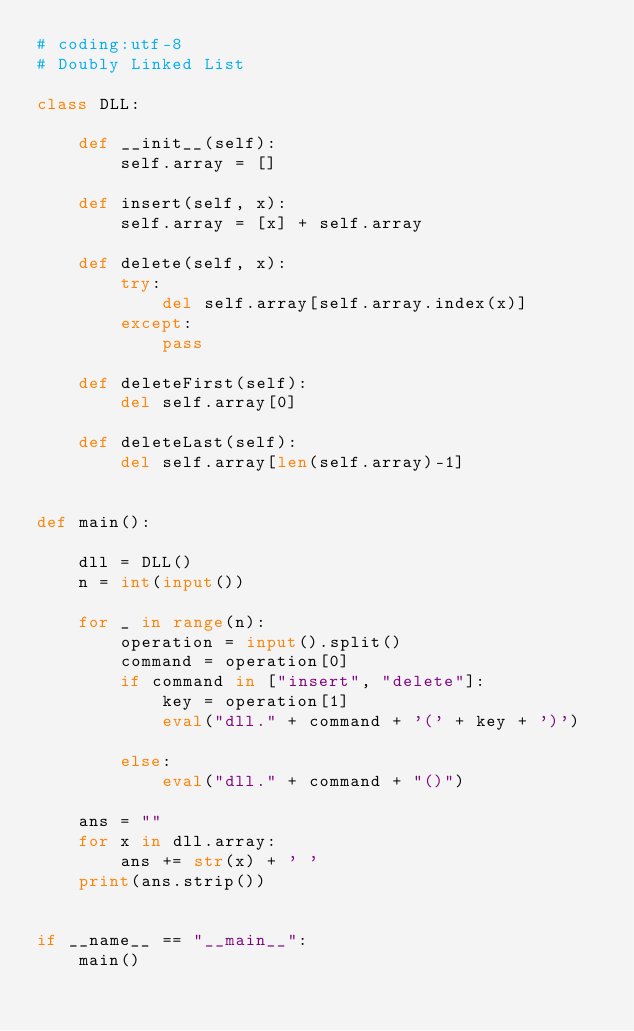<code> <loc_0><loc_0><loc_500><loc_500><_Python_># coding:utf-8
# Doubly Linked List

class DLL:

    def __init__(self):
        self.array = []

    def insert(self, x):
        self.array = [x] + self.array
    
    def delete(self, x):
        try:
            del self.array[self.array.index(x)]
        except:
            pass

    def deleteFirst(self):
        del self.array[0]

    def deleteLast(self):
        del self.array[len(self.array)-1]


def main():

    dll = DLL()
    n = int(input())

    for _ in range(n):
        operation = input().split()
        command = operation[0]
        if command in ["insert", "delete"]:
            key = operation[1]
            eval("dll." + command + '(' + key + ')')

        else:
            eval("dll." + command + "()")

    ans = ""
    for x in dll.array:
        ans += str(x) + ' '
    print(ans.strip())
        

if __name__ == "__main__":
    main()</code> 